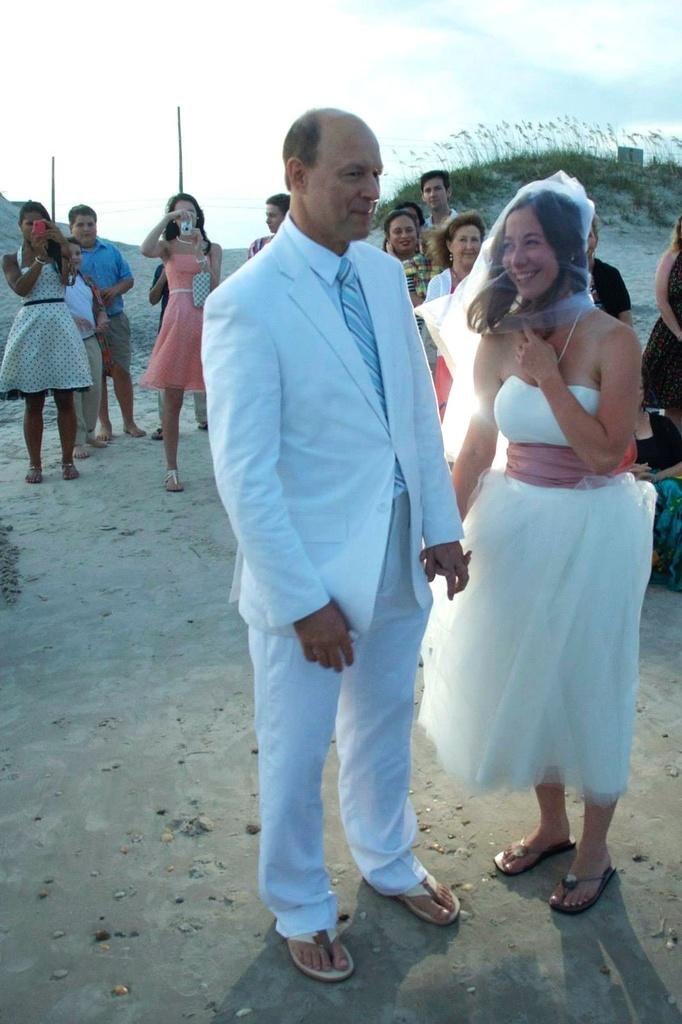Who is present in the image? There is a man and a woman in the image. What are the man and the woman doing? Both the man and the woman are smiling. Are there any other people in the image? Yes, there are other people standing behind them. What are these other people doing? These people are clicking pictures. What is the zinc content in the man's smile in the image? There is no information about the zinc content in the image, as it is not relevant to the subjects or actions depicted. 